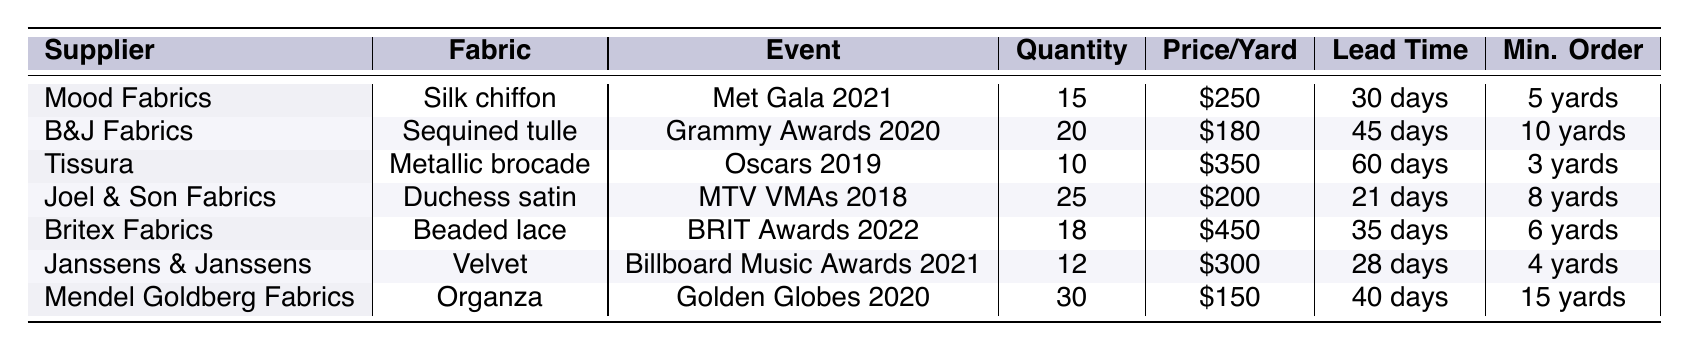What fabric did Mood Fabrics supply for the Met Gala 2021? According to the table, Mood Fabrics supplied silk chiffon for the Met Gala 2021 event.
Answer: Silk chiffon Which supplier had the highest price per yard? Looking at the prices per yard in the table, Britex Fabrics at $450 has the highest price.
Answer: Britex Fabrics What is the total quantity of fabric supplied for the Golden Globes 2020? The table states that Mendel Goldberg Fabrics supplied a total quantity of 30 yards for the Golden Globes 2020.
Answer: 30 yards Is the minimum order for Tissura less than the minimum order for Mood Fabrics? The minimum order for Tissura is 3 yards, and for Mood Fabrics, it is 5 yards. Since 3 is less than 5, the statement is true.
Answer: Yes What is the average lead time for the fabric suppliers? To find the average lead time, we sum all the lead times (30 + 45 + 60 + 21 + 35 + 28 + 40 = 259 days) and divide by the number of suppliers (7), which gives an average of 37 days (259/7 ≈ 37).
Answer: 37 days Which event had the least quantity of fabric supplied, and what was the amount? By examining the table, the event with the least quantity is the Oscars 2019, where 10 yards of Metallic brocade were supplied.
Answer: Oscars 2019, 10 yards If we combine the prices per yard for Velvet and Sequined tulle, what is the total cost? The price per yard for Velvet is $300 and for Sequined tulle is $180. Adding these together gives $300 + $180 = $480.
Answer: $480 Which supplier has the shortest lead time, and what is it? By reviewing the lead times, Joel & Son Fabrics has the shortest lead time of 21 days for Duchess satin.
Answer: Joel & Son Fabrics, 21 days How many more yards of fabric were supplied for the BRIT Awards 2022 than for the MTV VMAs 2018? The BRIT Awards received 18 yards and MTV VMAs received 25 yards. To find the difference, we calculate 25 - 18 = 7 yards.
Answer: 7 yards Based on the table, which fabric was used for the Grammy Awards 2020? The table indicates that Sequined tulle was used for the Grammy Awards 2020.
Answer: Sequined tulle 